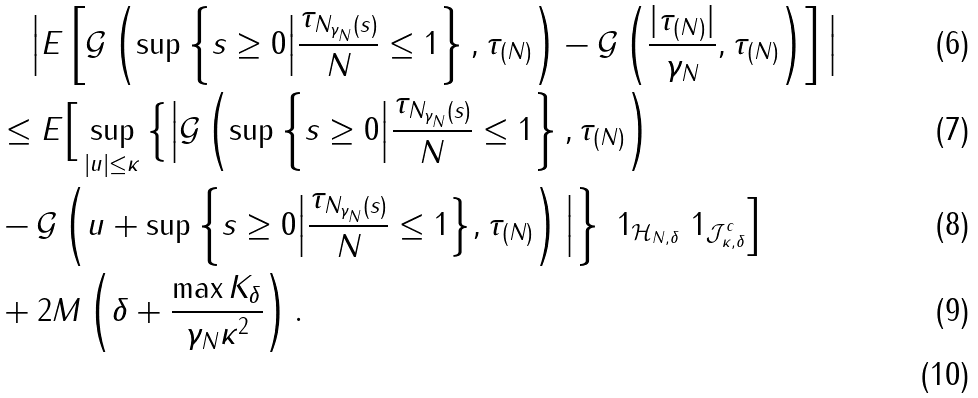<formula> <loc_0><loc_0><loc_500><loc_500>& \quad \Big | E \left [ \mathcal { G } \left ( \sup \left \{ s \geq 0 \Big | \frac { \tau _ { N _ { \gamma _ { N } } ( s ) } } { N } \leq 1 \right \} , \tau _ { ( N ) } \right ) - \mathcal { G } \left ( \frac { | \tau _ { ( N ) } | } { \gamma _ { N } } , \tau _ { ( N ) } \right ) \right ] \Big | \\ & \leq E \Big [ \sup _ { | u | \leq \kappa } \Big \{ \Big | \mathcal { G } \left ( \sup \left \{ s \geq 0 \Big | \frac { \tau _ { N _ { \gamma _ { N } } ( s ) } } { N } \leq 1 \right \} , \tau _ { ( N ) } \right ) \\ & - \mathcal { G } \left ( u + \sup \left \{ s \geq 0 \Big | \frac { \tau _ { N _ { \gamma _ { N } } ( s ) } } { N } \leq 1 \Big \} , \tau _ { ( N ) } \right ) \Big | \right \} \ 1 _ { \mathcal { H } _ { N , \delta } } \ 1 _ { \mathcal { J } _ { \kappa , \delta } ^ { c } } \Big ] \\ & + 2 M \left ( \delta + \frac { \max K _ { \delta } } { \gamma _ { N } \kappa ^ { 2 } } \right ) . \\</formula> 